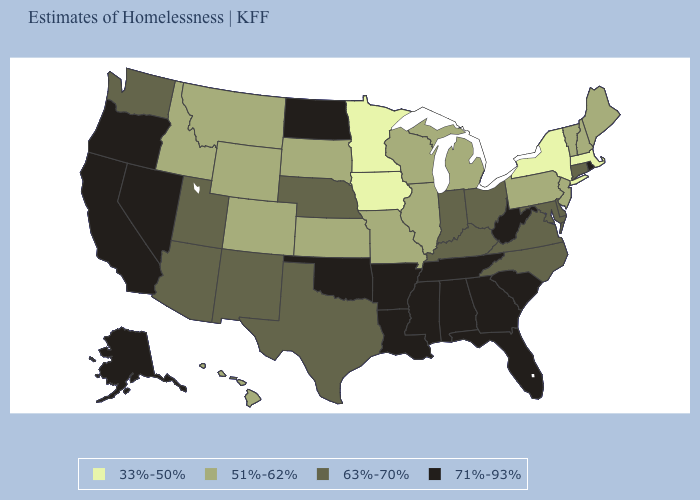Among the states that border Arizona , does Nevada have the highest value?
Concise answer only. Yes. Does Colorado have the lowest value in the West?
Short answer required. Yes. Name the states that have a value in the range 33%-50%?
Give a very brief answer. Iowa, Massachusetts, Minnesota, New York. Does Vermont have the lowest value in the Northeast?
Quick response, please. No. What is the highest value in the USA?
Quick response, please. 71%-93%. What is the lowest value in the Northeast?
Keep it brief. 33%-50%. Among the states that border North Dakota , which have the lowest value?
Answer briefly. Minnesota. Name the states that have a value in the range 63%-70%?
Be succinct. Arizona, Connecticut, Delaware, Indiana, Kentucky, Maryland, Nebraska, New Mexico, North Carolina, Ohio, Texas, Utah, Virginia, Washington. Name the states that have a value in the range 33%-50%?
Give a very brief answer. Iowa, Massachusetts, Minnesota, New York. Among the states that border Kentucky , does Indiana have the highest value?
Be succinct. No. How many symbols are there in the legend?
Concise answer only. 4. Name the states that have a value in the range 51%-62%?
Short answer required. Colorado, Hawaii, Idaho, Illinois, Kansas, Maine, Michigan, Missouri, Montana, New Hampshire, New Jersey, Pennsylvania, South Dakota, Vermont, Wisconsin, Wyoming. Does Alabama have the same value as California?
Answer briefly. Yes. Name the states that have a value in the range 71%-93%?
Short answer required. Alabama, Alaska, Arkansas, California, Florida, Georgia, Louisiana, Mississippi, Nevada, North Dakota, Oklahoma, Oregon, Rhode Island, South Carolina, Tennessee, West Virginia. Does Indiana have the same value as Missouri?
Be succinct. No. 